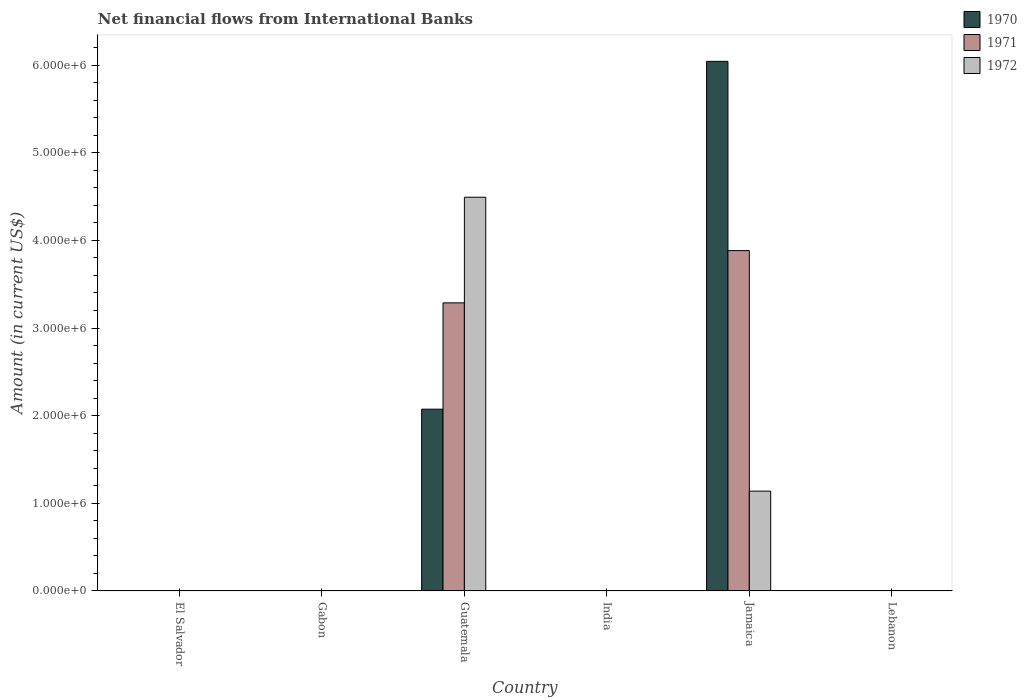How many different coloured bars are there?
Offer a terse response. 3. Are the number of bars per tick equal to the number of legend labels?
Offer a very short reply. No. Are the number of bars on each tick of the X-axis equal?
Make the answer very short. No. How many bars are there on the 4th tick from the left?
Provide a succinct answer. 0. How many bars are there on the 2nd tick from the right?
Make the answer very short. 3. What is the label of the 1st group of bars from the left?
Your answer should be compact. El Salvador. What is the net financial aid flows in 1971 in El Salvador?
Your answer should be very brief. 0. Across all countries, what is the maximum net financial aid flows in 1971?
Offer a terse response. 3.88e+06. Across all countries, what is the minimum net financial aid flows in 1971?
Give a very brief answer. 0. In which country was the net financial aid flows in 1972 maximum?
Provide a short and direct response. Guatemala. What is the total net financial aid flows in 1970 in the graph?
Your response must be concise. 8.12e+06. What is the difference between the net financial aid flows in 1970 in Guatemala and that in Jamaica?
Offer a very short reply. -3.97e+06. What is the difference between the net financial aid flows in 1970 in Guatemala and the net financial aid flows in 1972 in Lebanon?
Your answer should be very brief. 2.07e+06. What is the average net financial aid flows in 1971 per country?
Offer a terse response. 1.20e+06. What is the difference between the net financial aid flows of/in 1972 and net financial aid flows of/in 1971 in Guatemala?
Give a very brief answer. 1.20e+06. In how many countries, is the net financial aid flows in 1972 greater than 1200000 US$?
Provide a succinct answer. 1. What is the difference between the highest and the lowest net financial aid flows in 1972?
Your answer should be very brief. 4.49e+06. In how many countries, is the net financial aid flows in 1971 greater than the average net financial aid flows in 1971 taken over all countries?
Your answer should be very brief. 2. Is it the case that in every country, the sum of the net financial aid flows in 1971 and net financial aid flows in 1970 is greater than the net financial aid flows in 1972?
Give a very brief answer. No. How many countries are there in the graph?
Offer a very short reply. 6. Are the values on the major ticks of Y-axis written in scientific E-notation?
Ensure brevity in your answer.  Yes. Does the graph contain any zero values?
Provide a succinct answer. Yes. Where does the legend appear in the graph?
Offer a very short reply. Top right. How are the legend labels stacked?
Keep it short and to the point. Vertical. What is the title of the graph?
Offer a very short reply. Net financial flows from International Banks. Does "1992" appear as one of the legend labels in the graph?
Ensure brevity in your answer.  No. What is the label or title of the X-axis?
Your response must be concise. Country. What is the label or title of the Y-axis?
Offer a terse response. Amount (in current US$). What is the Amount (in current US$) of 1972 in El Salvador?
Provide a succinct answer. 0. What is the Amount (in current US$) in 1970 in Guatemala?
Ensure brevity in your answer.  2.07e+06. What is the Amount (in current US$) in 1971 in Guatemala?
Offer a terse response. 3.29e+06. What is the Amount (in current US$) in 1972 in Guatemala?
Offer a very short reply. 4.49e+06. What is the Amount (in current US$) of 1970 in India?
Keep it short and to the point. 0. What is the Amount (in current US$) in 1972 in India?
Your answer should be compact. 0. What is the Amount (in current US$) of 1970 in Jamaica?
Offer a terse response. 6.04e+06. What is the Amount (in current US$) in 1971 in Jamaica?
Your response must be concise. 3.88e+06. What is the Amount (in current US$) in 1972 in Jamaica?
Your answer should be compact. 1.14e+06. What is the Amount (in current US$) of 1970 in Lebanon?
Ensure brevity in your answer.  0. What is the Amount (in current US$) in 1972 in Lebanon?
Ensure brevity in your answer.  0. Across all countries, what is the maximum Amount (in current US$) in 1970?
Your answer should be very brief. 6.04e+06. Across all countries, what is the maximum Amount (in current US$) of 1971?
Give a very brief answer. 3.88e+06. Across all countries, what is the maximum Amount (in current US$) in 1972?
Offer a terse response. 4.49e+06. Across all countries, what is the minimum Amount (in current US$) of 1972?
Offer a terse response. 0. What is the total Amount (in current US$) of 1970 in the graph?
Give a very brief answer. 8.12e+06. What is the total Amount (in current US$) in 1971 in the graph?
Your response must be concise. 7.17e+06. What is the total Amount (in current US$) in 1972 in the graph?
Ensure brevity in your answer.  5.63e+06. What is the difference between the Amount (in current US$) of 1970 in Guatemala and that in Jamaica?
Offer a terse response. -3.97e+06. What is the difference between the Amount (in current US$) in 1971 in Guatemala and that in Jamaica?
Give a very brief answer. -5.96e+05. What is the difference between the Amount (in current US$) of 1972 in Guatemala and that in Jamaica?
Provide a short and direct response. 3.35e+06. What is the difference between the Amount (in current US$) of 1970 in Guatemala and the Amount (in current US$) of 1971 in Jamaica?
Give a very brief answer. -1.81e+06. What is the difference between the Amount (in current US$) of 1970 in Guatemala and the Amount (in current US$) of 1972 in Jamaica?
Make the answer very short. 9.35e+05. What is the difference between the Amount (in current US$) of 1971 in Guatemala and the Amount (in current US$) of 1972 in Jamaica?
Your response must be concise. 2.15e+06. What is the average Amount (in current US$) of 1970 per country?
Provide a succinct answer. 1.35e+06. What is the average Amount (in current US$) of 1971 per country?
Your answer should be very brief. 1.20e+06. What is the average Amount (in current US$) in 1972 per country?
Your answer should be compact. 9.38e+05. What is the difference between the Amount (in current US$) in 1970 and Amount (in current US$) in 1971 in Guatemala?
Make the answer very short. -1.21e+06. What is the difference between the Amount (in current US$) of 1970 and Amount (in current US$) of 1972 in Guatemala?
Keep it short and to the point. -2.42e+06. What is the difference between the Amount (in current US$) in 1971 and Amount (in current US$) in 1972 in Guatemala?
Your answer should be very brief. -1.20e+06. What is the difference between the Amount (in current US$) in 1970 and Amount (in current US$) in 1971 in Jamaica?
Offer a very short reply. 2.16e+06. What is the difference between the Amount (in current US$) in 1970 and Amount (in current US$) in 1972 in Jamaica?
Offer a very short reply. 4.90e+06. What is the difference between the Amount (in current US$) in 1971 and Amount (in current US$) in 1972 in Jamaica?
Provide a succinct answer. 2.74e+06. What is the ratio of the Amount (in current US$) of 1970 in Guatemala to that in Jamaica?
Provide a short and direct response. 0.34. What is the ratio of the Amount (in current US$) of 1971 in Guatemala to that in Jamaica?
Give a very brief answer. 0.85. What is the ratio of the Amount (in current US$) of 1972 in Guatemala to that in Jamaica?
Your response must be concise. 3.94. What is the difference between the highest and the lowest Amount (in current US$) of 1970?
Your answer should be very brief. 6.04e+06. What is the difference between the highest and the lowest Amount (in current US$) of 1971?
Make the answer very short. 3.88e+06. What is the difference between the highest and the lowest Amount (in current US$) in 1972?
Keep it short and to the point. 4.49e+06. 